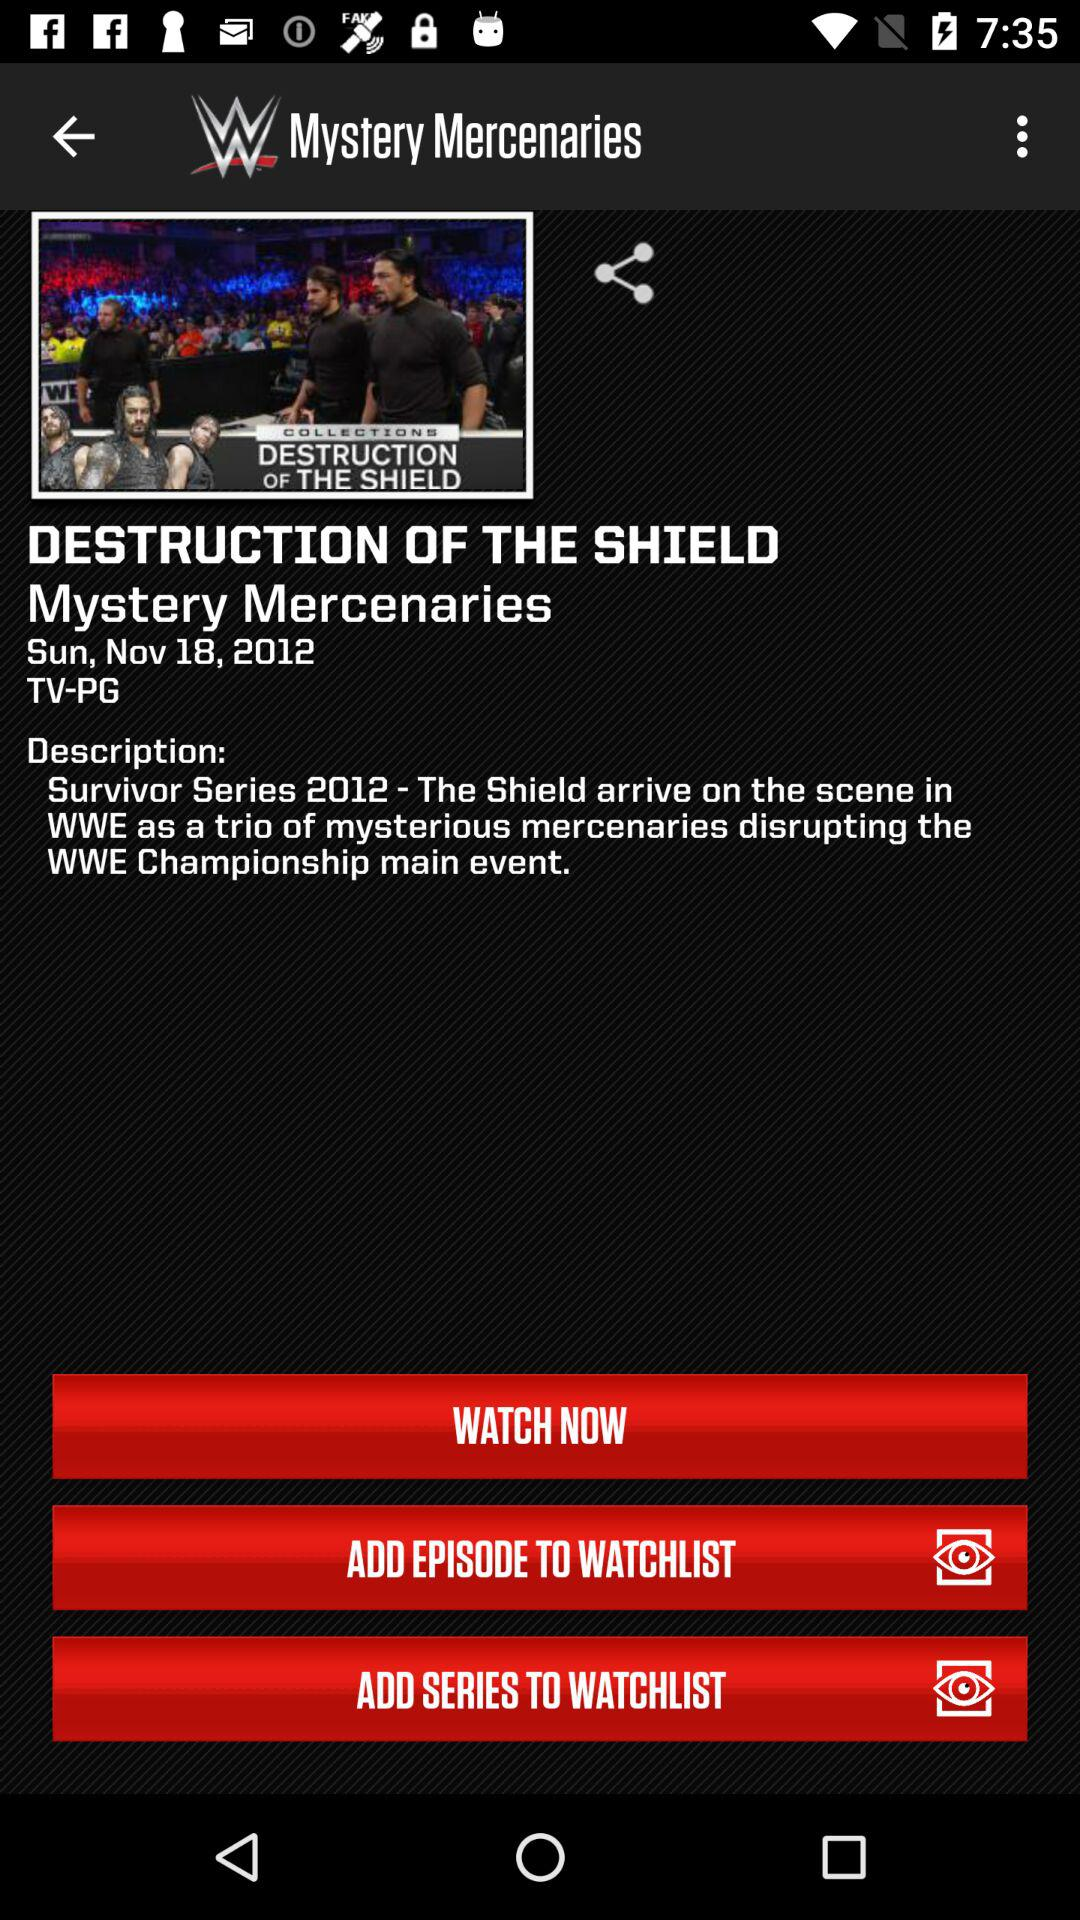What is the year of the "Survivor Series"? The year of the "Survivor Series" is 2012. 